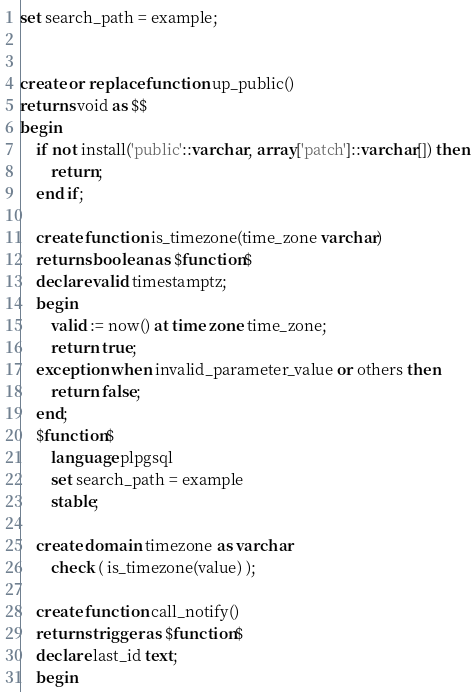Convert code to text. <code><loc_0><loc_0><loc_500><loc_500><_SQL_>set search_path = example;


create or replace function up_public()
returns void as $$
begin
    if not install('public'::varchar, array['patch']::varchar[]) then
        return;
    end if;

    create function is_timezone(time_zone varchar)
    returns boolean as $function$
    declare valid timestamptz;
    begin
        valid := now() at time zone time_zone;
        return true;
    exception when invalid_parameter_value or others then
        return false;
    end;
    $function$
        language plpgsql
        set search_path = example
        stable;

    create domain timezone as varchar
        check ( is_timezone(value) );

    create function call_notify()
    returns trigger as $function$
    declare last_id text;
    begin</code> 